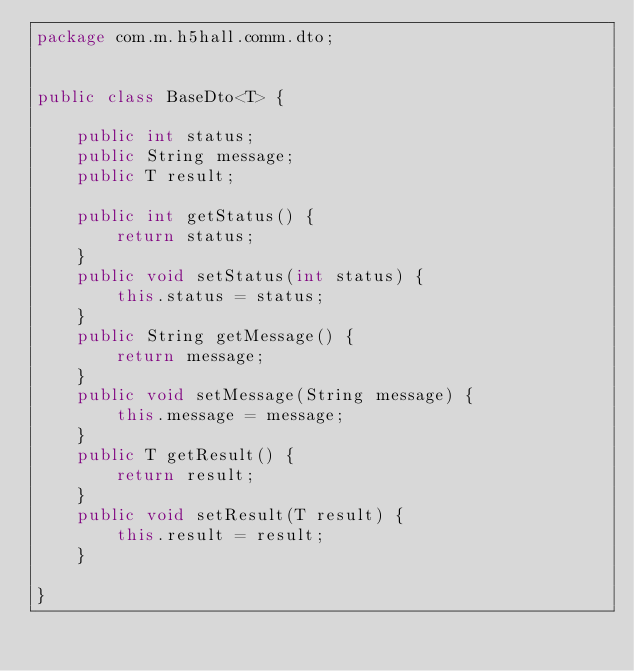Convert code to text. <code><loc_0><loc_0><loc_500><loc_500><_Java_>package com.m.h5hall.comm.dto;


public class BaseDto<T> {
	
	public int status;
	public String message;
	public T result;
	
	public int getStatus() {
		return status;
	}
	public void setStatus(int status) {
		this.status = status;
	}
	public String getMessage() {
		return message;
	}
	public void setMessage(String message) {
		this.message = message;
	}
	public T getResult() {
		return result;
	}
	public void setResult(T result) {
		this.result = result;
	}
	
}
</code> 